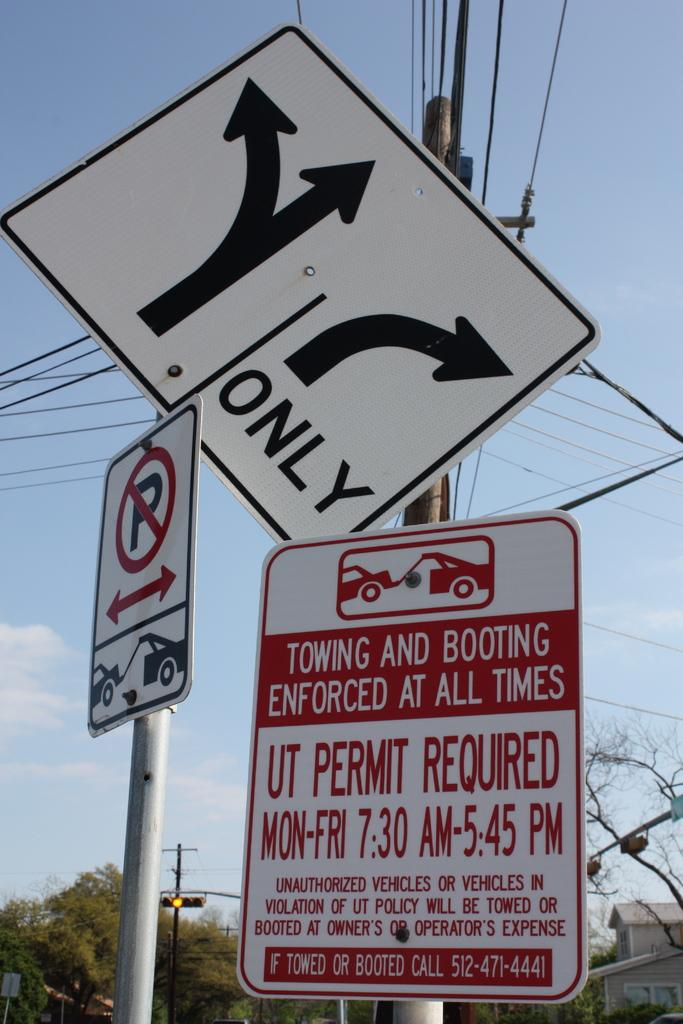<image>
Provide a brief description of the given image. A sign says that towing and booting is enforced at all times here. 